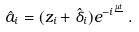<formula> <loc_0><loc_0><loc_500><loc_500>\hat { a } _ { i } = ( z _ { i } + \hat { \delta } _ { i } ) e ^ { - i \frac { \mu t } { } } \, .</formula> 